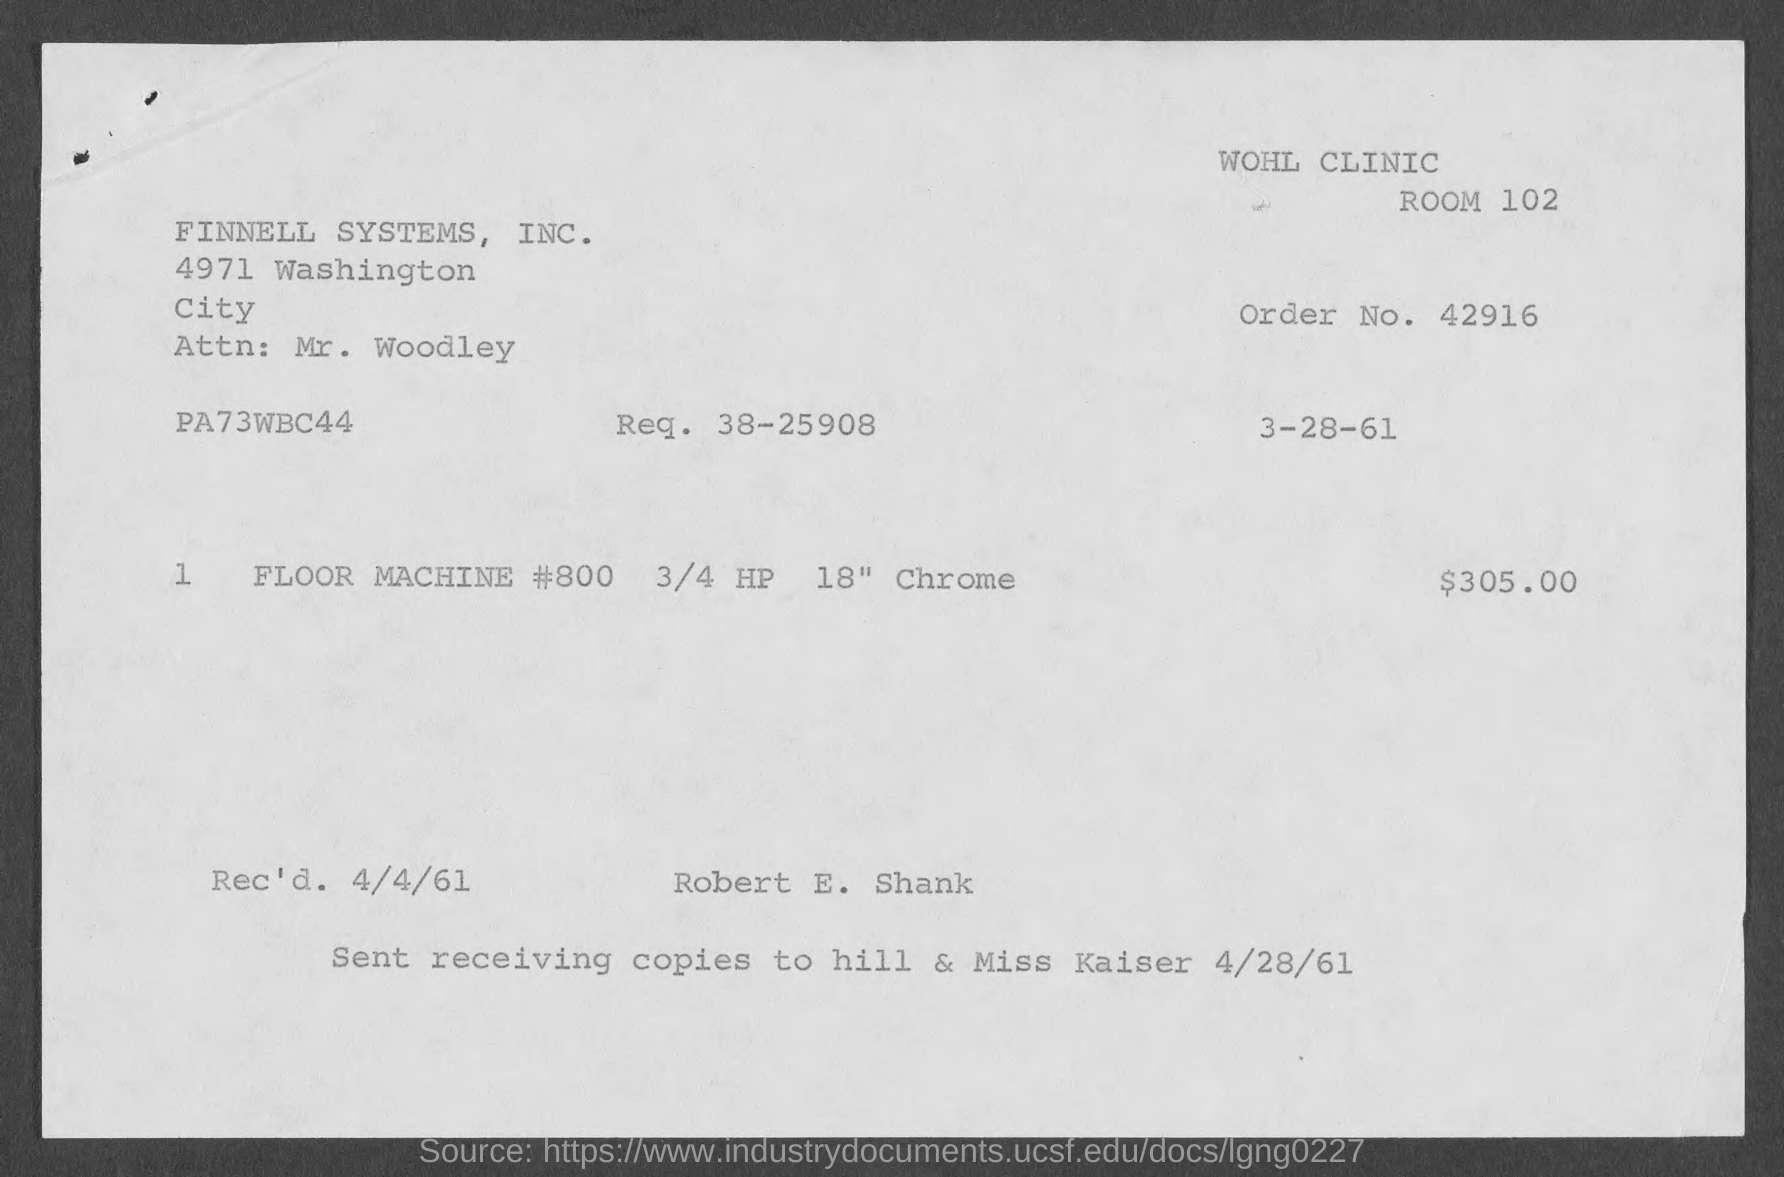Highlight a few significant elements in this photo. What is the request number? The order number is 4,2916. The document was received on April 4, 1961. 